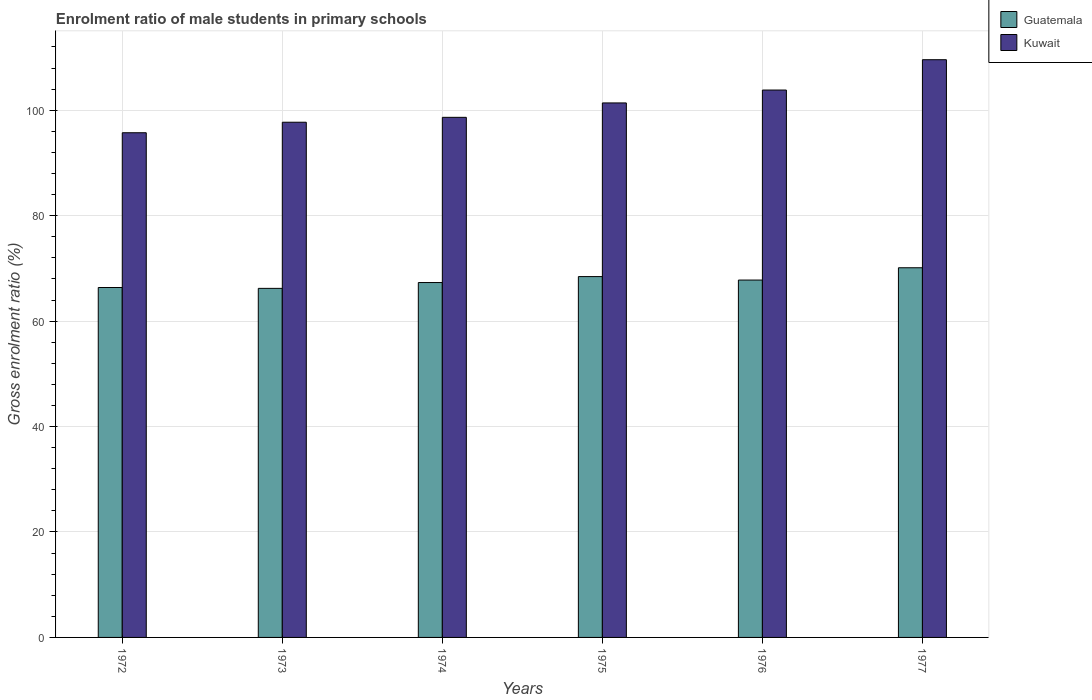Are the number of bars per tick equal to the number of legend labels?
Make the answer very short. Yes. Are the number of bars on each tick of the X-axis equal?
Give a very brief answer. Yes. How many bars are there on the 3rd tick from the left?
Provide a short and direct response. 2. What is the label of the 6th group of bars from the left?
Give a very brief answer. 1977. In how many cases, is the number of bars for a given year not equal to the number of legend labels?
Offer a terse response. 0. What is the enrolment ratio of male students in primary schools in Guatemala in 1974?
Offer a very short reply. 67.32. Across all years, what is the maximum enrolment ratio of male students in primary schools in Guatemala?
Your answer should be compact. 70.12. Across all years, what is the minimum enrolment ratio of male students in primary schools in Kuwait?
Offer a very short reply. 95.73. What is the total enrolment ratio of male students in primary schools in Guatemala in the graph?
Make the answer very short. 406.26. What is the difference between the enrolment ratio of male students in primary schools in Kuwait in 1972 and that in 1974?
Offer a terse response. -2.92. What is the difference between the enrolment ratio of male students in primary schools in Kuwait in 1973 and the enrolment ratio of male students in primary schools in Guatemala in 1972?
Give a very brief answer. 31.35. What is the average enrolment ratio of male students in primary schools in Guatemala per year?
Keep it short and to the point. 67.71. In the year 1973, what is the difference between the enrolment ratio of male students in primary schools in Guatemala and enrolment ratio of male students in primary schools in Kuwait?
Your response must be concise. -31.52. In how many years, is the enrolment ratio of male students in primary schools in Guatemala greater than 80 %?
Keep it short and to the point. 0. What is the ratio of the enrolment ratio of male students in primary schools in Kuwait in 1976 to that in 1977?
Keep it short and to the point. 0.95. Is the enrolment ratio of male students in primary schools in Kuwait in 1972 less than that in 1973?
Offer a very short reply. Yes. Is the difference between the enrolment ratio of male students in primary schools in Guatemala in 1972 and 1977 greater than the difference between the enrolment ratio of male students in primary schools in Kuwait in 1972 and 1977?
Provide a succinct answer. Yes. What is the difference between the highest and the second highest enrolment ratio of male students in primary schools in Guatemala?
Offer a terse response. 1.67. What is the difference between the highest and the lowest enrolment ratio of male students in primary schools in Guatemala?
Give a very brief answer. 3.91. In how many years, is the enrolment ratio of male students in primary schools in Guatemala greater than the average enrolment ratio of male students in primary schools in Guatemala taken over all years?
Your response must be concise. 3. Is the sum of the enrolment ratio of male students in primary schools in Kuwait in 1975 and 1976 greater than the maximum enrolment ratio of male students in primary schools in Guatemala across all years?
Your answer should be very brief. Yes. What does the 1st bar from the left in 1973 represents?
Give a very brief answer. Guatemala. What does the 2nd bar from the right in 1974 represents?
Keep it short and to the point. Guatemala. How many bars are there?
Ensure brevity in your answer.  12. Are all the bars in the graph horizontal?
Ensure brevity in your answer.  No. How many years are there in the graph?
Your answer should be very brief. 6. What is the difference between two consecutive major ticks on the Y-axis?
Ensure brevity in your answer.  20. Are the values on the major ticks of Y-axis written in scientific E-notation?
Your answer should be compact. No. Does the graph contain any zero values?
Make the answer very short. No. Does the graph contain grids?
Ensure brevity in your answer.  Yes. Where does the legend appear in the graph?
Keep it short and to the point. Top right. What is the title of the graph?
Provide a succinct answer. Enrolment ratio of male students in primary schools. What is the label or title of the X-axis?
Make the answer very short. Years. What is the Gross enrolment ratio (%) of Guatemala in 1972?
Keep it short and to the point. 66.37. What is the Gross enrolment ratio (%) in Kuwait in 1972?
Provide a short and direct response. 95.73. What is the Gross enrolment ratio (%) in Guatemala in 1973?
Your answer should be compact. 66.21. What is the Gross enrolment ratio (%) in Kuwait in 1973?
Your answer should be compact. 97.73. What is the Gross enrolment ratio (%) of Guatemala in 1974?
Provide a short and direct response. 67.32. What is the Gross enrolment ratio (%) of Kuwait in 1974?
Ensure brevity in your answer.  98.65. What is the Gross enrolment ratio (%) of Guatemala in 1975?
Keep it short and to the point. 68.45. What is the Gross enrolment ratio (%) in Kuwait in 1975?
Make the answer very short. 101.39. What is the Gross enrolment ratio (%) in Guatemala in 1976?
Ensure brevity in your answer.  67.79. What is the Gross enrolment ratio (%) in Kuwait in 1976?
Your answer should be compact. 103.83. What is the Gross enrolment ratio (%) of Guatemala in 1977?
Give a very brief answer. 70.12. What is the Gross enrolment ratio (%) of Kuwait in 1977?
Provide a succinct answer. 109.58. Across all years, what is the maximum Gross enrolment ratio (%) of Guatemala?
Provide a short and direct response. 70.12. Across all years, what is the maximum Gross enrolment ratio (%) of Kuwait?
Provide a short and direct response. 109.58. Across all years, what is the minimum Gross enrolment ratio (%) in Guatemala?
Ensure brevity in your answer.  66.21. Across all years, what is the minimum Gross enrolment ratio (%) of Kuwait?
Make the answer very short. 95.73. What is the total Gross enrolment ratio (%) of Guatemala in the graph?
Your answer should be compact. 406.26. What is the total Gross enrolment ratio (%) in Kuwait in the graph?
Offer a terse response. 606.91. What is the difference between the Gross enrolment ratio (%) of Guatemala in 1972 and that in 1973?
Keep it short and to the point. 0.16. What is the difference between the Gross enrolment ratio (%) of Kuwait in 1972 and that in 1973?
Your response must be concise. -2. What is the difference between the Gross enrolment ratio (%) in Guatemala in 1972 and that in 1974?
Your answer should be compact. -0.94. What is the difference between the Gross enrolment ratio (%) of Kuwait in 1972 and that in 1974?
Make the answer very short. -2.92. What is the difference between the Gross enrolment ratio (%) of Guatemala in 1972 and that in 1975?
Make the answer very short. -2.07. What is the difference between the Gross enrolment ratio (%) in Kuwait in 1972 and that in 1975?
Give a very brief answer. -5.66. What is the difference between the Gross enrolment ratio (%) of Guatemala in 1972 and that in 1976?
Make the answer very short. -1.41. What is the difference between the Gross enrolment ratio (%) in Kuwait in 1972 and that in 1976?
Your answer should be compact. -8.1. What is the difference between the Gross enrolment ratio (%) of Guatemala in 1972 and that in 1977?
Provide a succinct answer. -3.74. What is the difference between the Gross enrolment ratio (%) of Kuwait in 1972 and that in 1977?
Give a very brief answer. -13.85. What is the difference between the Gross enrolment ratio (%) in Guatemala in 1973 and that in 1974?
Give a very brief answer. -1.11. What is the difference between the Gross enrolment ratio (%) of Kuwait in 1973 and that in 1974?
Offer a terse response. -0.93. What is the difference between the Gross enrolment ratio (%) in Guatemala in 1973 and that in 1975?
Your answer should be compact. -2.24. What is the difference between the Gross enrolment ratio (%) in Kuwait in 1973 and that in 1975?
Your response must be concise. -3.66. What is the difference between the Gross enrolment ratio (%) in Guatemala in 1973 and that in 1976?
Give a very brief answer. -1.58. What is the difference between the Gross enrolment ratio (%) in Kuwait in 1973 and that in 1976?
Ensure brevity in your answer.  -6.1. What is the difference between the Gross enrolment ratio (%) in Guatemala in 1973 and that in 1977?
Your answer should be very brief. -3.91. What is the difference between the Gross enrolment ratio (%) in Kuwait in 1973 and that in 1977?
Your response must be concise. -11.86. What is the difference between the Gross enrolment ratio (%) of Guatemala in 1974 and that in 1975?
Provide a short and direct response. -1.13. What is the difference between the Gross enrolment ratio (%) of Kuwait in 1974 and that in 1975?
Ensure brevity in your answer.  -2.74. What is the difference between the Gross enrolment ratio (%) of Guatemala in 1974 and that in 1976?
Your response must be concise. -0.47. What is the difference between the Gross enrolment ratio (%) of Kuwait in 1974 and that in 1976?
Keep it short and to the point. -5.18. What is the difference between the Gross enrolment ratio (%) of Guatemala in 1974 and that in 1977?
Offer a very short reply. -2.8. What is the difference between the Gross enrolment ratio (%) of Kuwait in 1974 and that in 1977?
Provide a short and direct response. -10.93. What is the difference between the Gross enrolment ratio (%) in Guatemala in 1975 and that in 1976?
Provide a succinct answer. 0.66. What is the difference between the Gross enrolment ratio (%) of Kuwait in 1975 and that in 1976?
Make the answer very short. -2.44. What is the difference between the Gross enrolment ratio (%) of Guatemala in 1975 and that in 1977?
Keep it short and to the point. -1.67. What is the difference between the Gross enrolment ratio (%) in Kuwait in 1975 and that in 1977?
Give a very brief answer. -8.2. What is the difference between the Gross enrolment ratio (%) in Guatemala in 1976 and that in 1977?
Provide a succinct answer. -2.33. What is the difference between the Gross enrolment ratio (%) in Kuwait in 1976 and that in 1977?
Make the answer very short. -5.75. What is the difference between the Gross enrolment ratio (%) of Guatemala in 1972 and the Gross enrolment ratio (%) of Kuwait in 1973?
Offer a terse response. -31.35. What is the difference between the Gross enrolment ratio (%) of Guatemala in 1972 and the Gross enrolment ratio (%) of Kuwait in 1974?
Your answer should be compact. -32.28. What is the difference between the Gross enrolment ratio (%) of Guatemala in 1972 and the Gross enrolment ratio (%) of Kuwait in 1975?
Offer a very short reply. -35.01. What is the difference between the Gross enrolment ratio (%) in Guatemala in 1972 and the Gross enrolment ratio (%) in Kuwait in 1976?
Provide a succinct answer. -37.46. What is the difference between the Gross enrolment ratio (%) of Guatemala in 1972 and the Gross enrolment ratio (%) of Kuwait in 1977?
Provide a succinct answer. -43.21. What is the difference between the Gross enrolment ratio (%) of Guatemala in 1973 and the Gross enrolment ratio (%) of Kuwait in 1974?
Provide a short and direct response. -32.44. What is the difference between the Gross enrolment ratio (%) of Guatemala in 1973 and the Gross enrolment ratio (%) of Kuwait in 1975?
Your response must be concise. -35.18. What is the difference between the Gross enrolment ratio (%) in Guatemala in 1973 and the Gross enrolment ratio (%) in Kuwait in 1976?
Your response must be concise. -37.62. What is the difference between the Gross enrolment ratio (%) of Guatemala in 1973 and the Gross enrolment ratio (%) of Kuwait in 1977?
Offer a terse response. -43.37. What is the difference between the Gross enrolment ratio (%) in Guatemala in 1974 and the Gross enrolment ratio (%) in Kuwait in 1975?
Your response must be concise. -34.07. What is the difference between the Gross enrolment ratio (%) in Guatemala in 1974 and the Gross enrolment ratio (%) in Kuwait in 1976?
Provide a short and direct response. -36.51. What is the difference between the Gross enrolment ratio (%) of Guatemala in 1974 and the Gross enrolment ratio (%) of Kuwait in 1977?
Provide a succinct answer. -42.27. What is the difference between the Gross enrolment ratio (%) in Guatemala in 1975 and the Gross enrolment ratio (%) in Kuwait in 1976?
Keep it short and to the point. -35.38. What is the difference between the Gross enrolment ratio (%) of Guatemala in 1975 and the Gross enrolment ratio (%) of Kuwait in 1977?
Keep it short and to the point. -41.14. What is the difference between the Gross enrolment ratio (%) in Guatemala in 1976 and the Gross enrolment ratio (%) in Kuwait in 1977?
Offer a very short reply. -41.8. What is the average Gross enrolment ratio (%) of Guatemala per year?
Your answer should be compact. 67.71. What is the average Gross enrolment ratio (%) of Kuwait per year?
Offer a terse response. 101.15. In the year 1972, what is the difference between the Gross enrolment ratio (%) in Guatemala and Gross enrolment ratio (%) in Kuwait?
Offer a very short reply. -29.36. In the year 1973, what is the difference between the Gross enrolment ratio (%) of Guatemala and Gross enrolment ratio (%) of Kuwait?
Make the answer very short. -31.52. In the year 1974, what is the difference between the Gross enrolment ratio (%) of Guatemala and Gross enrolment ratio (%) of Kuwait?
Give a very brief answer. -31.34. In the year 1975, what is the difference between the Gross enrolment ratio (%) in Guatemala and Gross enrolment ratio (%) in Kuwait?
Provide a succinct answer. -32.94. In the year 1976, what is the difference between the Gross enrolment ratio (%) of Guatemala and Gross enrolment ratio (%) of Kuwait?
Provide a short and direct response. -36.04. In the year 1977, what is the difference between the Gross enrolment ratio (%) of Guatemala and Gross enrolment ratio (%) of Kuwait?
Offer a very short reply. -39.46. What is the ratio of the Gross enrolment ratio (%) of Kuwait in 1972 to that in 1973?
Offer a terse response. 0.98. What is the ratio of the Gross enrolment ratio (%) in Kuwait in 1972 to that in 1974?
Provide a succinct answer. 0.97. What is the ratio of the Gross enrolment ratio (%) in Guatemala in 1972 to that in 1975?
Provide a short and direct response. 0.97. What is the ratio of the Gross enrolment ratio (%) of Kuwait in 1972 to that in 1975?
Keep it short and to the point. 0.94. What is the ratio of the Gross enrolment ratio (%) in Guatemala in 1972 to that in 1976?
Ensure brevity in your answer.  0.98. What is the ratio of the Gross enrolment ratio (%) in Kuwait in 1972 to that in 1976?
Offer a very short reply. 0.92. What is the ratio of the Gross enrolment ratio (%) in Guatemala in 1972 to that in 1977?
Keep it short and to the point. 0.95. What is the ratio of the Gross enrolment ratio (%) of Kuwait in 1972 to that in 1977?
Keep it short and to the point. 0.87. What is the ratio of the Gross enrolment ratio (%) of Guatemala in 1973 to that in 1974?
Provide a short and direct response. 0.98. What is the ratio of the Gross enrolment ratio (%) in Kuwait in 1973 to that in 1974?
Ensure brevity in your answer.  0.99. What is the ratio of the Gross enrolment ratio (%) in Guatemala in 1973 to that in 1975?
Keep it short and to the point. 0.97. What is the ratio of the Gross enrolment ratio (%) of Kuwait in 1973 to that in 1975?
Your answer should be very brief. 0.96. What is the ratio of the Gross enrolment ratio (%) of Guatemala in 1973 to that in 1976?
Offer a very short reply. 0.98. What is the ratio of the Gross enrolment ratio (%) of Kuwait in 1973 to that in 1976?
Give a very brief answer. 0.94. What is the ratio of the Gross enrolment ratio (%) of Guatemala in 1973 to that in 1977?
Keep it short and to the point. 0.94. What is the ratio of the Gross enrolment ratio (%) of Kuwait in 1973 to that in 1977?
Provide a short and direct response. 0.89. What is the ratio of the Gross enrolment ratio (%) in Guatemala in 1974 to that in 1975?
Your answer should be compact. 0.98. What is the ratio of the Gross enrolment ratio (%) of Kuwait in 1974 to that in 1975?
Your answer should be very brief. 0.97. What is the ratio of the Gross enrolment ratio (%) in Kuwait in 1974 to that in 1976?
Your response must be concise. 0.95. What is the ratio of the Gross enrolment ratio (%) in Kuwait in 1974 to that in 1977?
Your answer should be very brief. 0.9. What is the ratio of the Gross enrolment ratio (%) in Guatemala in 1975 to that in 1976?
Offer a very short reply. 1.01. What is the ratio of the Gross enrolment ratio (%) of Kuwait in 1975 to that in 1976?
Provide a succinct answer. 0.98. What is the ratio of the Gross enrolment ratio (%) in Guatemala in 1975 to that in 1977?
Give a very brief answer. 0.98. What is the ratio of the Gross enrolment ratio (%) in Kuwait in 1975 to that in 1977?
Offer a terse response. 0.93. What is the ratio of the Gross enrolment ratio (%) of Guatemala in 1976 to that in 1977?
Make the answer very short. 0.97. What is the ratio of the Gross enrolment ratio (%) of Kuwait in 1976 to that in 1977?
Offer a terse response. 0.95. What is the difference between the highest and the second highest Gross enrolment ratio (%) of Guatemala?
Give a very brief answer. 1.67. What is the difference between the highest and the second highest Gross enrolment ratio (%) of Kuwait?
Offer a very short reply. 5.75. What is the difference between the highest and the lowest Gross enrolment ratio (%) of Guatemala?
Provide a short and direct response. 3.91. What is the difference between the highest and the lowest Gross enrolment ratio (%) of Kuwait?
Give a very brief answer. 13.85. 